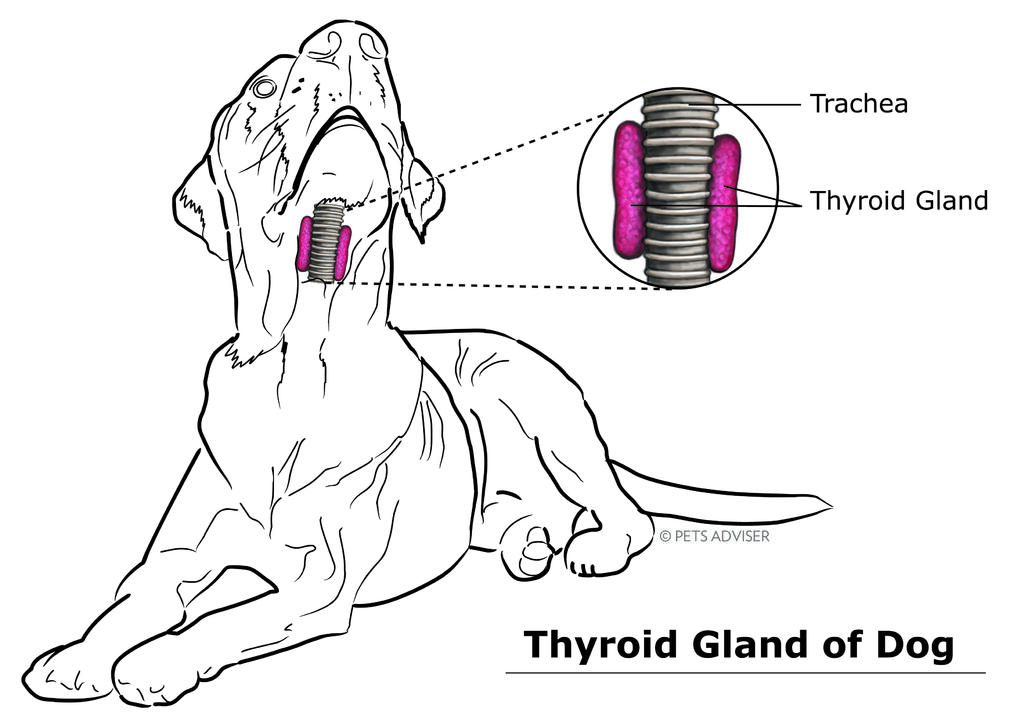What is depicted in the drawing in the image? There is a drawing of a dog in the image. What can be found on the right side of the image? There is text and a picture on the right side of the image. Where is the text located at the bottom of the image? There is text at the bottom of the image. What type of flame can be seen in the image? There is no flame present in the image. How many waves are visible in the image? There are no waves visible in the image. 